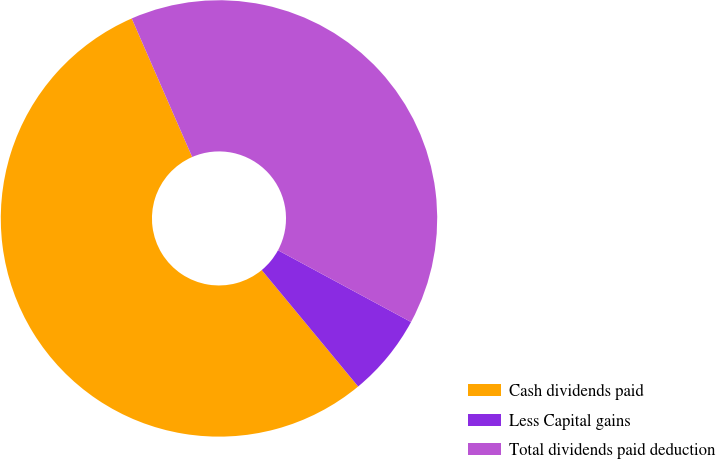Convert chart to OTSL. <chart><loc_0><loc_0><loc_500><loc_500><pie_chart><fcel>Cash dividends paid<fcel>Less Capital gains<fcel>Total dividends paid deduction<nl><fcel>54.46%<fcel>6.12%<fcel>39.42%<nl></chart> 